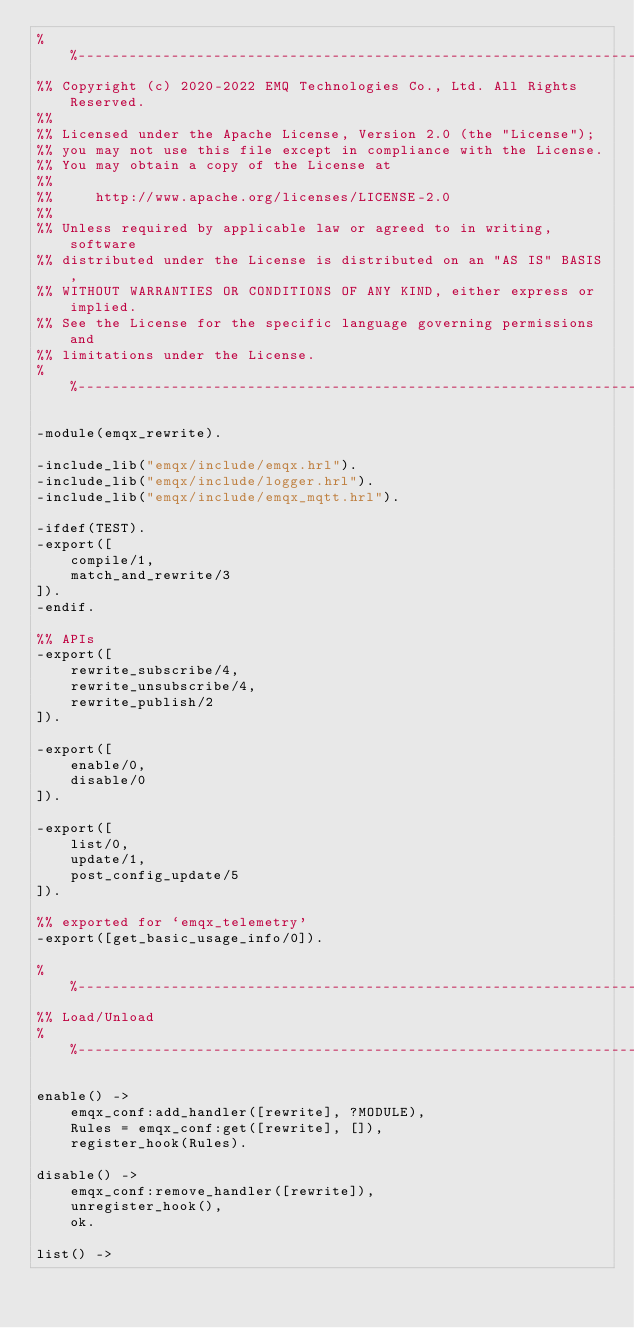Convert code to text. <code><loc_0><loc_0><loc_500><loc_500><_Erlang_>%%--------------------------------------------------------------------
%% Copyright (c) 2020-2022 EMQ Technologies Co., Ltd. All Rights Reserved.
%%
%% Licensed under the Apache License, Version 2.0 (the "License");
%% you may not use this file except in compliance with the License.
%% You may obtain a copy of the License at
%%
%%     http://www.apache.org/licenses/LICENSE-2.0
%%
%% Unless required by applicable law or agreed to in writing, software
%% distributed under the License is distributed on an "AS IS" BASIS,
%% WITHOUT WARRANTIES OR CONDITIONS OF ANY KIND, either express or implied.
%% See the License for the specific language governing permissions and
%% limitations under the License.
%%--------------------------------------------------------------------

-module(emqx_rewrite).

-include_lib("emqx/include/emqx.hrl").
-include_lib("emqx/include/logger.hrl").
-include_lib("emqx/include/emqx_mqtt.hrl").

-ifdef(TEST).
-export([
    compile/1,
    match_and_rewrite/3
]).
-endif.

%% APIs
-export([
    rewrite_subscribe/4,
    rewrite_unsubscribe/4,
    rewrite_publish/2
]).

-export([
    enable/0,
    disable/0
]).

-export([
    list/0,
    update/1,
    post_config_update/5
]).

%% exported for `emqx_telemetry'
-export([get_basic_usage_info/0]).

%%--------------------------------------------------------------------
%% Load/Unload
%%--------------------------------------------------------------------

enable() ->
    emqx_conf:add_handler([rewrite], ?MODULE),
    Rules = emqx_conf:get([rewrite], []),
    register_hook(Rules).

disable() ->
    emqx_conf:remove_handler([rewrite]),
    unregister_hook(),
    ok.

list() -></code> 